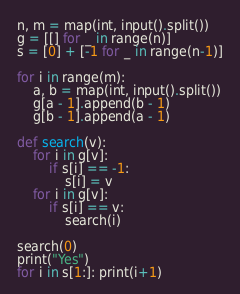<code> <loc_0><loc_0><loc_500><loc_500><_Python_>n, m = map(int, input().split())
g = [[] for _ in range(n)]
s = [0] + [-1 for _ in range(n-1)]

for i in range(m):
    a, b = map(int, input().split())
    g[a - 1].append(b - 1)
    g[b - 1].append(a - 1)
    
def search(v):
    for i in g[v]:
        if s[i] == -1:
            s[i] = v
    for i in g[v]:
        if s[i] == v:
            search(i)

search(0)
print("Yes")
for i in s[1:]: print(i+1)</code> 